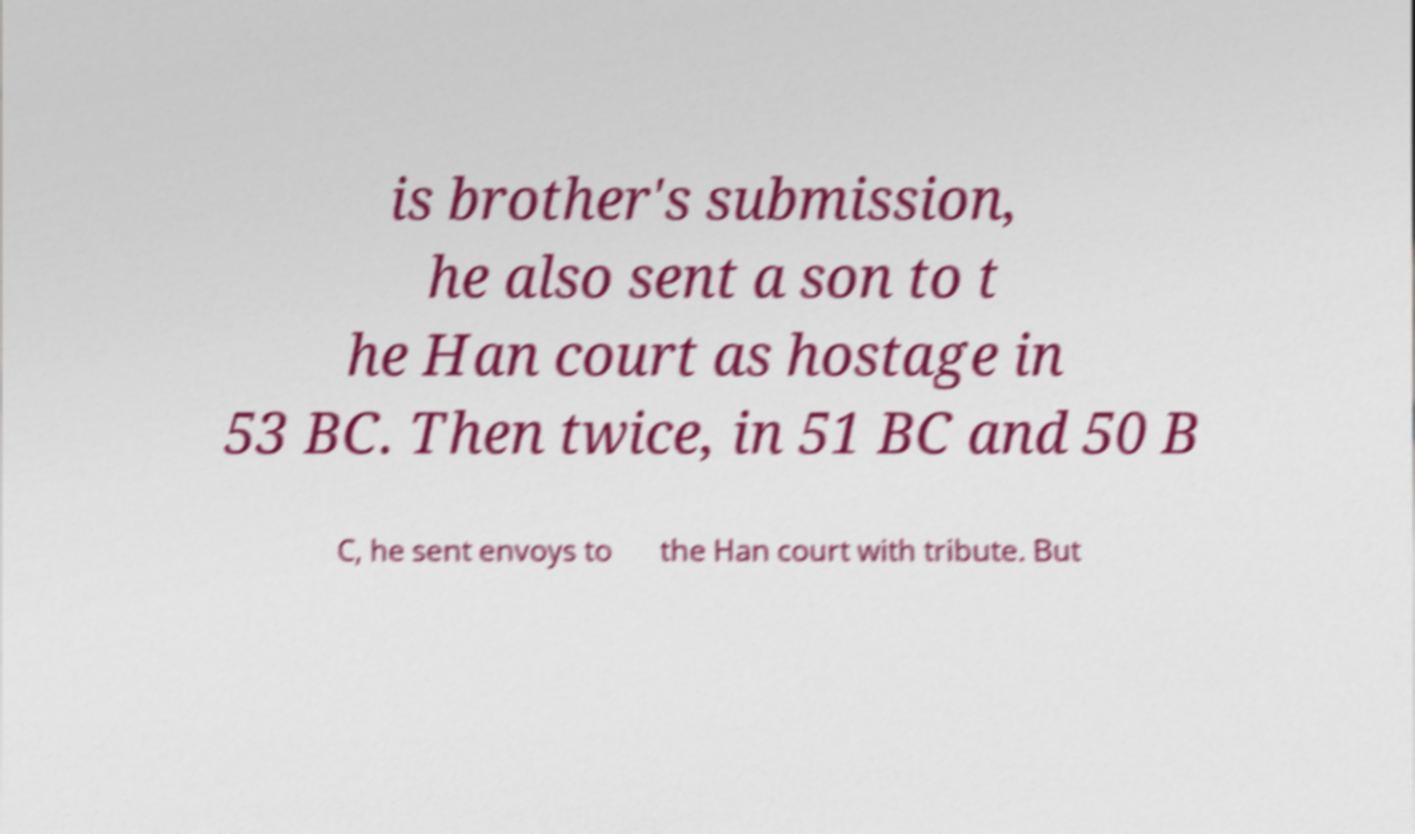I need the written content from this picture converted into text. Can you do that? is brother's submission, he also sent a son to t he Han court as hostage in 53 BC. Then twice, in 51 BC and 50 B C, he sent envoys to the Han court with tribute. But 